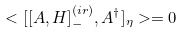<formula> <loc_0><loc_0><loc_500><loc_500>< [ [ A , H ] ^ { ( i r ) } _ { - } , A ^ { \dagger } ] _ { \eta } > = 0</formula> 